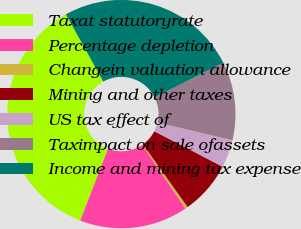Convert chart to OTSL. <chart><loc_0><loc_0><loc_500><loc_500><pie_chart><fcel>Taxat statutoryrate<fcel>Percentage depletion<fcel>Changein valuation allowance<fcel>Mining and other taxes<fcel>US tax effect of<fcel>Taximpact on sale ofassets<fcel>Income and mining tax expense<nl><fcel>36.08%<fcel>15.34%<fcel>0.38%<fcel>7.52%<fcel>3.95%<fcel>11.09%<fcel>25.65%<nl></chart> 